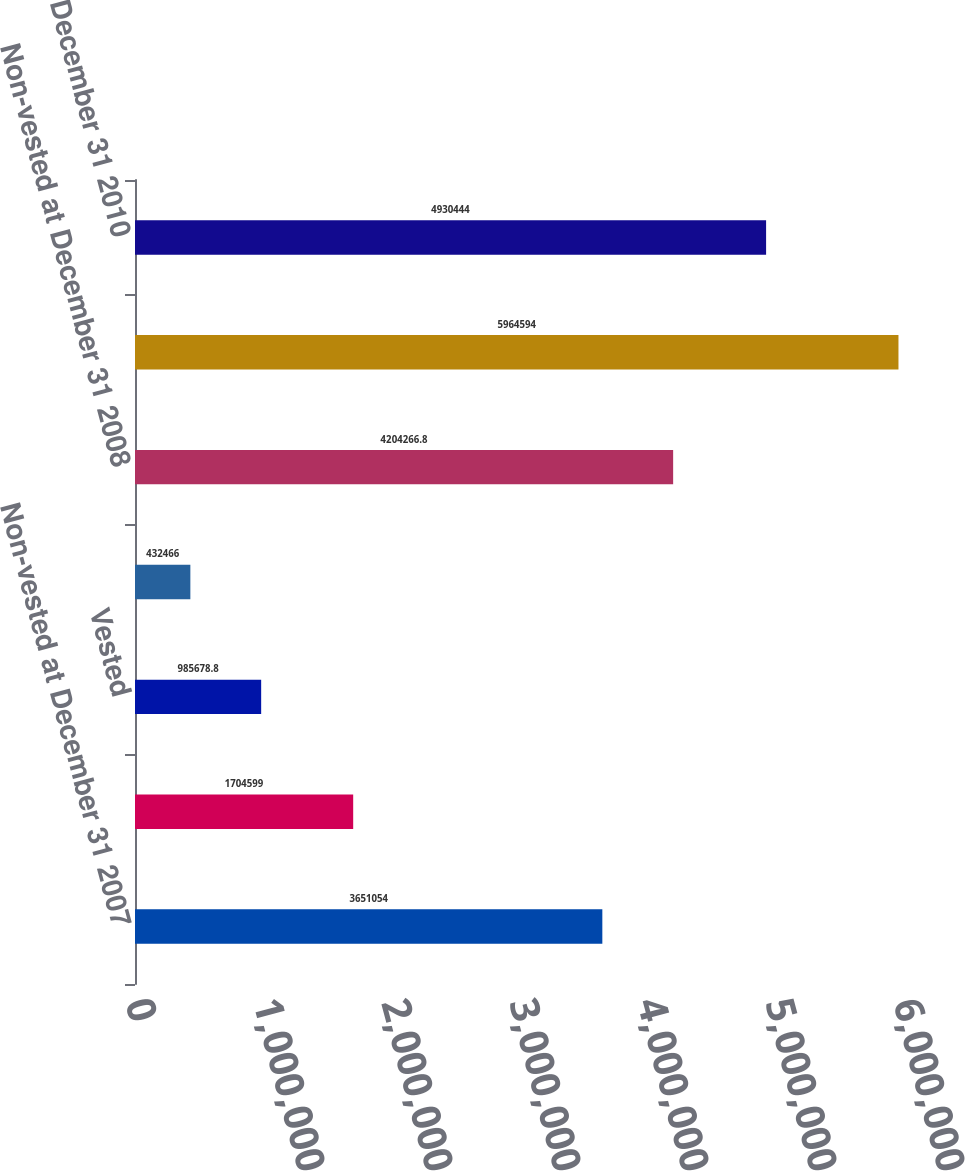<chart> <loc_0><loc_0><loc_500><loc_500><bar_chart><fcel>Non-vested at December 31 2007<fcel>Granted<fcel>Vested<fcel>Forfeited<fcel>Non-vested at December 31 2008<fcel>Non-vested at December 31 2009<fcel>Non-vested at December 31 2010<nl><fcel>3.65105e+06<fcel>1.7046e+06<fcel>985679<fcel>432466<fcel>4.20427e+06<fcel>5.96459e+06<fcel>4.93044e+06<nl></chart> 